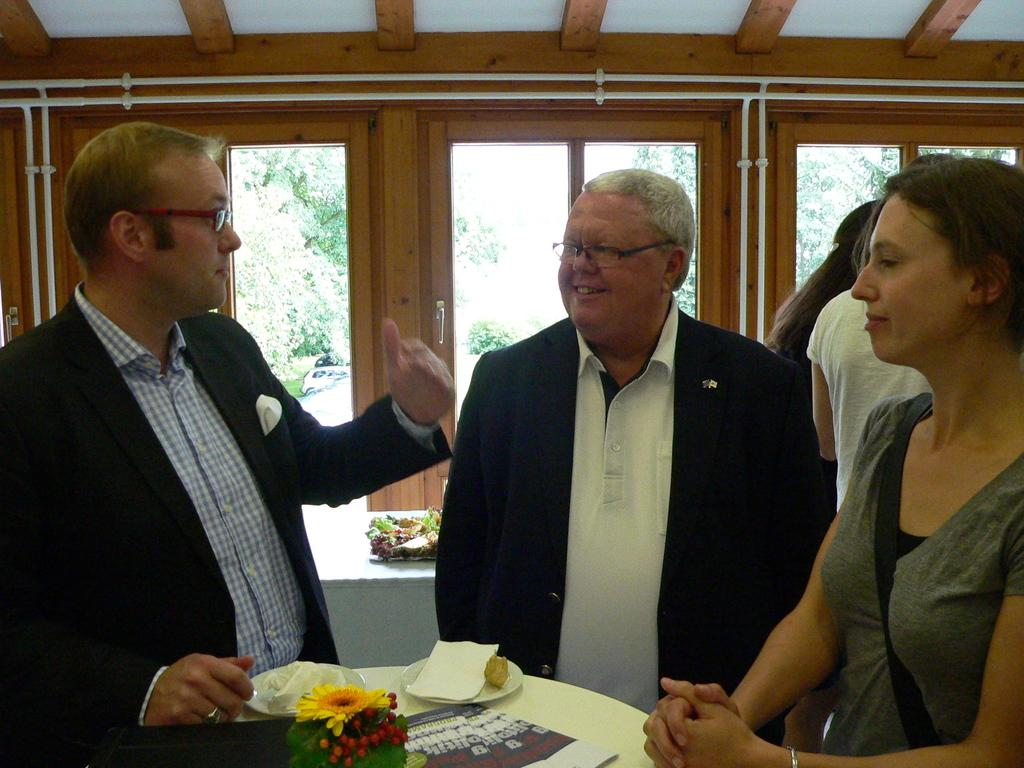How many people are in the image? There are people in the image, but the exact number is not specified. What is in front of the people? There is a table in front of the people. What can be found on the table? There are plates, flowers, and other objects on the table. What is visible through the glass window? Trees and a vehicle are visible through the glass window. What color are the trousers worn by the goldfish in the image? There are no goldfish or trousers present in the image. What is the view from the window in the image? The facts provided do not mention a view from the window, only that trees and a vehicle are visible through the glass window. 